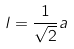<formula> <loc_0><loc_0><loc_500><loc_500>l = \frac { 1 } { \sqrt { 2 } } a</formula> 